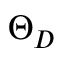Convert formula to latex. <formula><loc_0><loc_0><loc_500><loc_500>\Theta _ { D }</formula> 